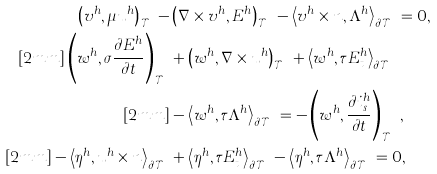Convert formula to latex. <formula><loc_0><loc_0><loc_500><loc_500>\left ( v ^ { h } , \mu u ^ { h } \right ) _ { \mathcal { T } ^ { h } } - & \left ( \nabla \times v ^ { h } , E ^ { h } \right ) _ { \mathcal { T } ^ { h } } - \left < v ^ { h } \times n , \Lambda ^ { h } \right > _ { \partial \mathcal { T } ^ { h } } = 0 , \\ [ 2 m m ] \left ( w ^ { h } , \boldsymbol \sigma \frac { \partial E ^ { h } } { \partial t } \right ) _ { \mathcal { T } ^ { h } } & + \left ( w ^ { h } , \nabla \times u ^ { h } \right ) _ { \mathcal { T } ^ { h } } + \left < w ^ { h } , \tau E ^ { h } _ { t } \right > _ { \partial \mathcal { T } ^ { h } } \\ [ 2 m m ] & - \left < w ^ { h } , \tau \Lambda ^ { h } \right > _ { \partial \mathcal { T } ^ { h } } = - \left ( w ^ { h } , \frac { \partial i _ { s } ^ { h } } { \partial t } \right ) _ { \mathcal { T } ^ { h } } , \\ [ 2 m m ] - \left < \eta ^ { h } , u ^ { h } \times n \right > _ { \partial \mathcal { T } ^ { h } } & + \left < \eta ^ { h } , \tau E ^ { h } _ { t } \right > _ { \partial \mathcal { T } ^ { h } } - \left < \eta ^ { h } , \tau \Lambda ^ { h } \right > _ { \partial \mathcal { T } ^ { h } } = 0 ,</formula> 